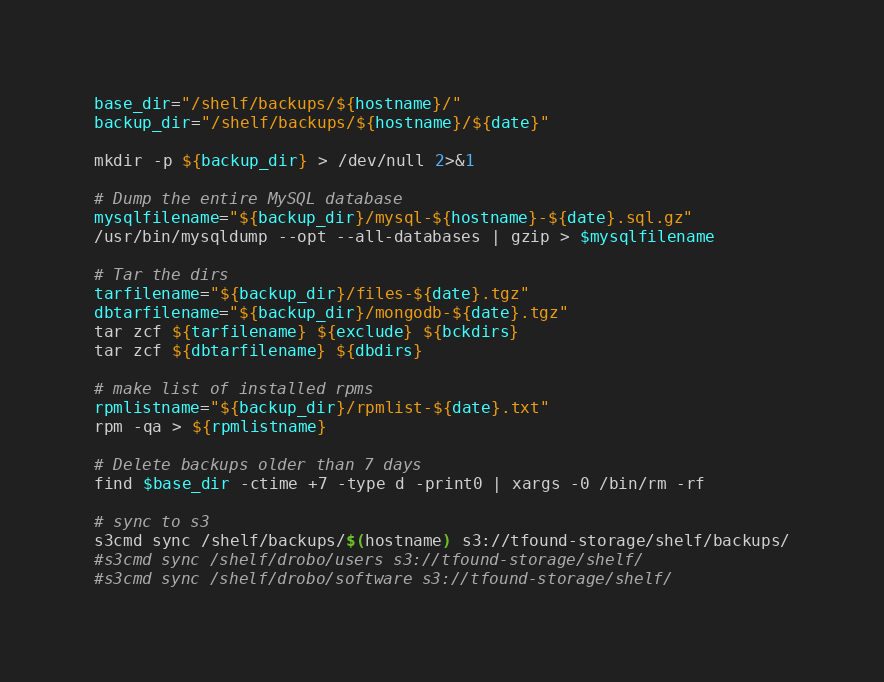Convert code to text. <code><loc_0><loc_0><loc_500><loc_500><_Bash_>base_dir="/shelf/backups/${hostname}/"
backup_dir="/shelf/backups/${hostname}/${date}"

mkdir -p ${backup_dir} > /dev/null 2>&1

# Dump the entire MySQL database
mysqlfilename="${backup_dir}/mysql-${hostname}-${date}.sql.gz"
/usr/bin/mysqldump --opt --all-databases | gzip > $mysqlfilename

# Tar the dirs
tarfilename="${backup_dir}/files-${date}.tgz"
dbtarfilename="${backup_dir}/mongodb-${date}.tgz"
tar zcf ${tarfilename} ${exclude} ${bckdirs}
tar zcf ${dbtarfilename} ${dbdirs}

# make list of installed rpms
rpmlistname="${backup_dir}/rpmlist-${date}.txt"
rpm -qa > ${rpmlistname}

# Delete backups older than 7 days
find $base_dir -ctime +7 -type d -print0 | xargs -0 /bin/rm -rf

# sync to s3
s3cmd sync /shelf/backups/$(hostname) s3://tfound-storage/shelf/backups/
#s3cmd sync /shelf/drobo/users s3://tfound-storage/shelf/
#s3cmd sync /shelf/drobo/software s3://tfound-storage/shelf/
</code> 